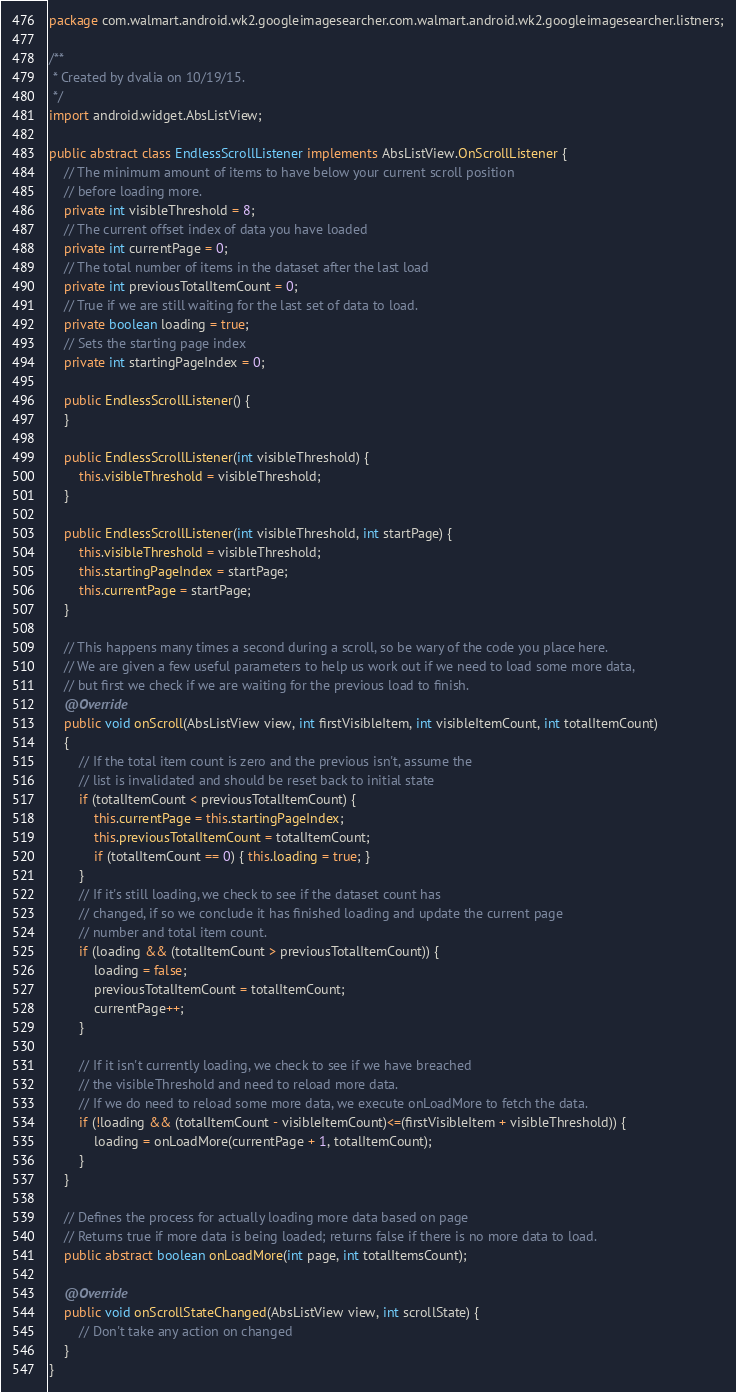<code> <loc_0><loc_0><loc_500><loc_500><_Java_>package com.walmart.android.wk2.googleimagesearcher.com.walmart.android.wk2.googleimagesearcher.listners;

/**
 * Created by dvalia on 10/19/15.
 */
import android.widget.AbsListView;

public abstract class EndlessScrollListener implements AbsListView.OnScrollListener {
    // The minimum amount of items to have below your current scroll position
    // before loading more.
    private int visibleThreshold = 8;
    // The current offset index of data you have loaded
    private int currentPage = 0;
    // The total number of items in the dataset after the last load
    private int previousTotalItemCount = 0;
    // True if we are still waiting for the last set of data to load.
    private boolean loading = true;
    // Sets the starting page index
    private int startingPageIndex = 0;

    public EndlessScrollListener() {
    }

    public EndlessScrollListener(int visibleThreshold) {
        this.visibleThreshold = visibleThreshold;
    }

    public EndlessScrollListener(int visibleThreshold, int startPage) {
        this.visibleThreshold = visibleThreshold;
        this.startingPageIndex = startPage;
        this.currentPage = startPage;
    }

    // This happens many times a second during a scroll, so be wary of the code you place here.
    // We are given a few useful parameters to help us work out if we need to load some more data,
    // but first we check if we are waiting for the previous load to finish.
    @Override
    public void onScroll(AbsListView view, int firstVisibleItem, int visibleItemCount, int totalItemCount)
    {
        // If the total item count is zero and the previous isn't, assume the
        // list is invalidated and should be reset back to initial state
        if (totalItemCount < previousTotalItemCount) {
            this.currentPage = this.startingPageIndex;
            this.previousTotalItemCount = totalItemCount;
            if (totalItemCount == 0) { this.loading = true; }
        }
        // If it's still loading, we check to see if the dataset count has
        // changed, if so we conclude it has finished loading and update the current page
        // number and total item count.
        if (loading && (totalItemCount > previousTotalItemCount)) {
            loading = false;
            previousTotalItemCount = totalItemCount;
            currentPage++;
        }

        // If it isn't currently loading, we check to see if we have breached
        // the visibleThreshold and need to reload more data.
        // If we do need to reload some more data, we execute onLoadMore to fetch the data.
        if (!loading && (totalItemCount - visibleItemCount)<=(firstVisibleItem + visibleThreshold)) {
            loading = onLoadMore(currentPage + 1, totalItemCount);
        }
    }

    // Defines the process for actually loading more data based on page
    // Returns true if more data is being loaded; returns false if there is no more data to load.
    public abstract boolean onLoadMore(int page, int totalItemsCount);

    @Override
    public void onScrollStateChanged(AbsListView view, int scrollState) {
        // Don't take any action on changed
    }
}</code> 